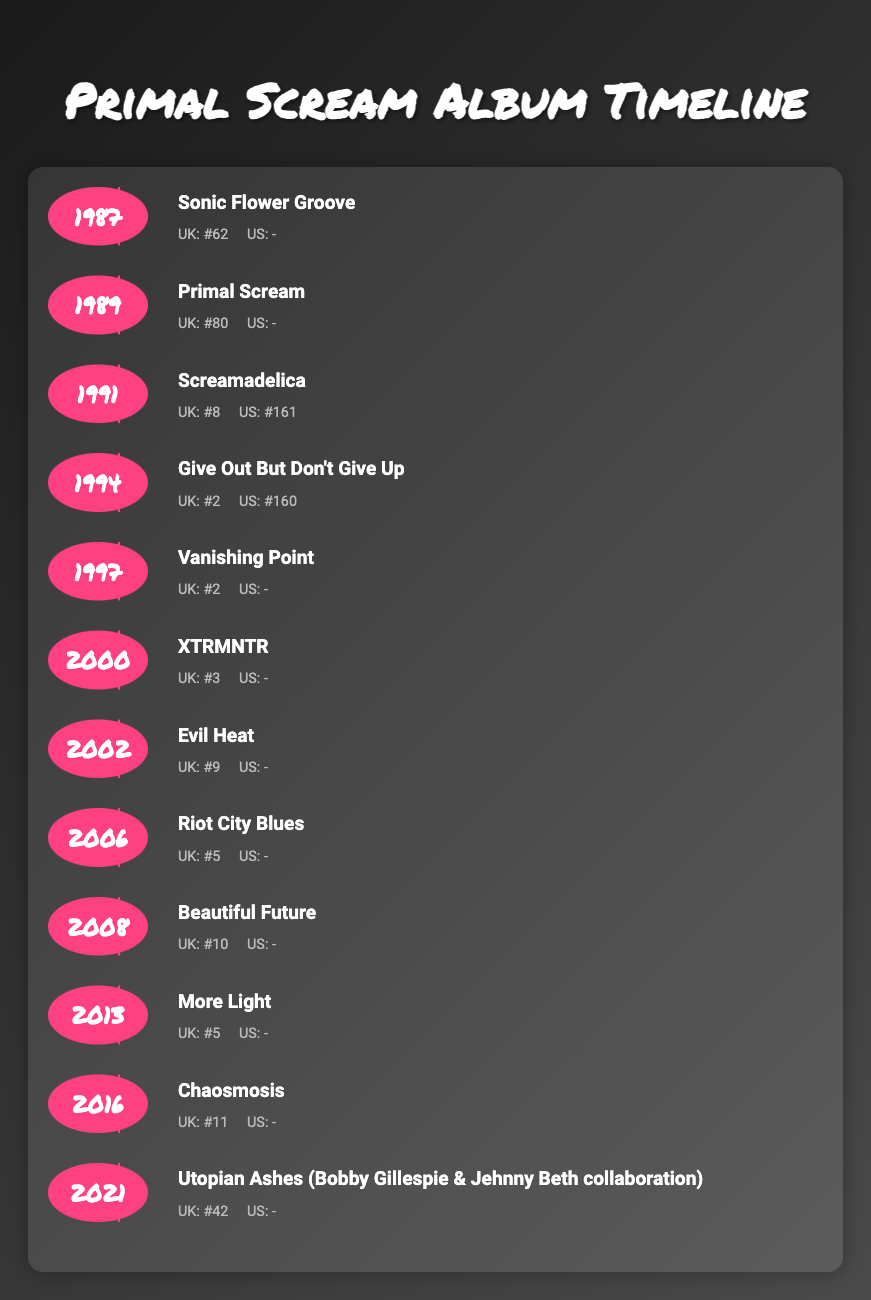What was Primal Scream's debut album and when was it released? The table shows that the debut album is "Sonic Flower Groove," released in 1987.
Answer: Sonic Flower Groove, 1987 Which album released in 1994 achieved the highest chart position? According to the chart positions in the table, "Give Out But Don't Give Up" released in 1994 reached #2 in the UK, which is higher than any other album from that year.
Answer: Give Out But Don't Give Up What is the average UK chart position of all albums released by Primal Scream? To find the average, sum the UK chart positions of all albums: 62 + 80 + 8 + 2 + 2 + 3 + 9 + 5 + 10 + 5 + 11 + 42 =  189. There are 12 albums, so we divide: 189 / 12 = 15.75.
Answer: 15.75 Did any of Primal Scream's albums reach the top position in the UK charts? Reviewing the chart positions in the table, none of the albums reached #1, as the highest position shown is #2.
Answer: No Which album released between 2000 and 2010 had the highest UK chart position? The albums in this range are "XTRMNTR" (3), "Evil Heat" (9), "Riot City Blues" (5), and "Beautiful Future" (10). The highest position is from "XTRMNTR" at #3.
Answer: XTRMNTR What is the difference in UK chart position between "Screamadelica" and "Utopian Ashes"? "Screamadelica" reached #8, and "Utopian Ashes" reached #42 in the UK. The difference is calculated as 42 - 8 = 34.
Answer: 34 Which album had both UK and US chart positions? The table indicates that "Screamadelica" is the only album with both UK (#8) and US (#161) chart positions.
Answer: Screamadelica What is the trend of Primal Scream's chart performance over the years? Evaluating the table indicates fluctuating success, with "Screamadelica" at #8 (1991) and "Give Out But Don't Give Up" at #2 (1994) being highs, with several albums charting lower in subsequent years.
Answer: Fluctuating success with highs and lows 